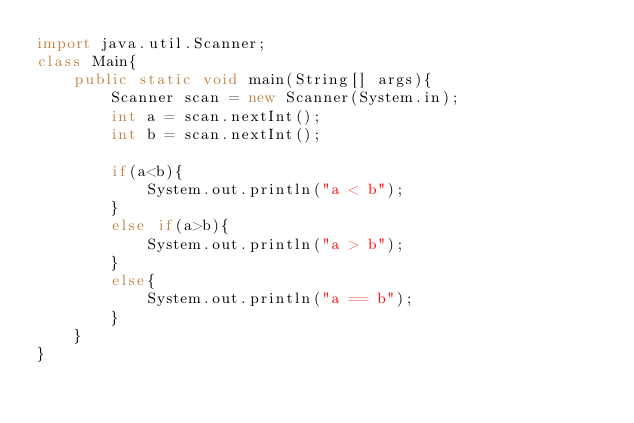Convert code to text. <code><loc_0><loc_0><loc_500><loc_500><_Java_>import java.util.Scanner;
class Main{
    public static void main(String[] args){
        Scanner scan = new Scanner(System.in);
        int a = scan.nextInt();
        int b = scan.nextInt();
        
        if(a<b){
            System.out.println("a < b");
        }
        else if(a>b){
            System.out.println("a > b");
        }
        else{
            System.out.println("a == b");
        }
    }
}
</code> 